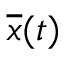Convert formula to latex. <formula><loc_0><loc_0><loc_500><loc_500>{ \overline { x } } ( t )</formula> 